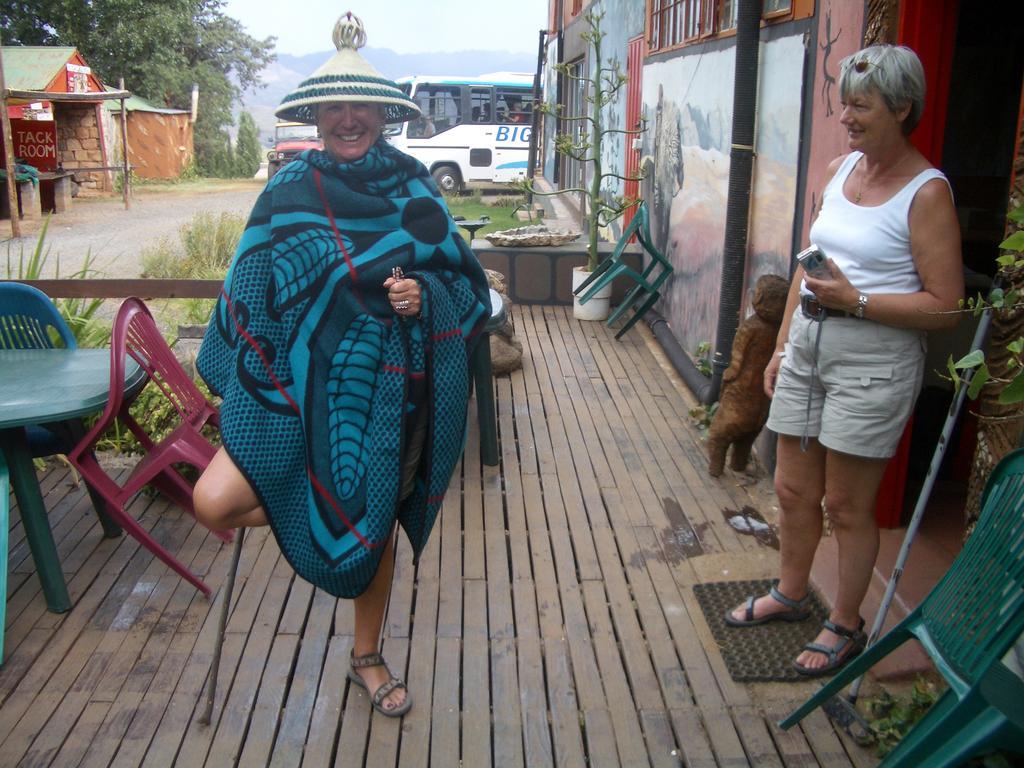Can you describe this image briefly? In the center of the image, we can see a lady wearing a hat and a blanket. On the right, there is a person holding a camera. In the background, there are chairs, sheds, trees, vehicles on the road and we can see plants, tables, windows, sticks and there is a floor. At the top, there is sky. 